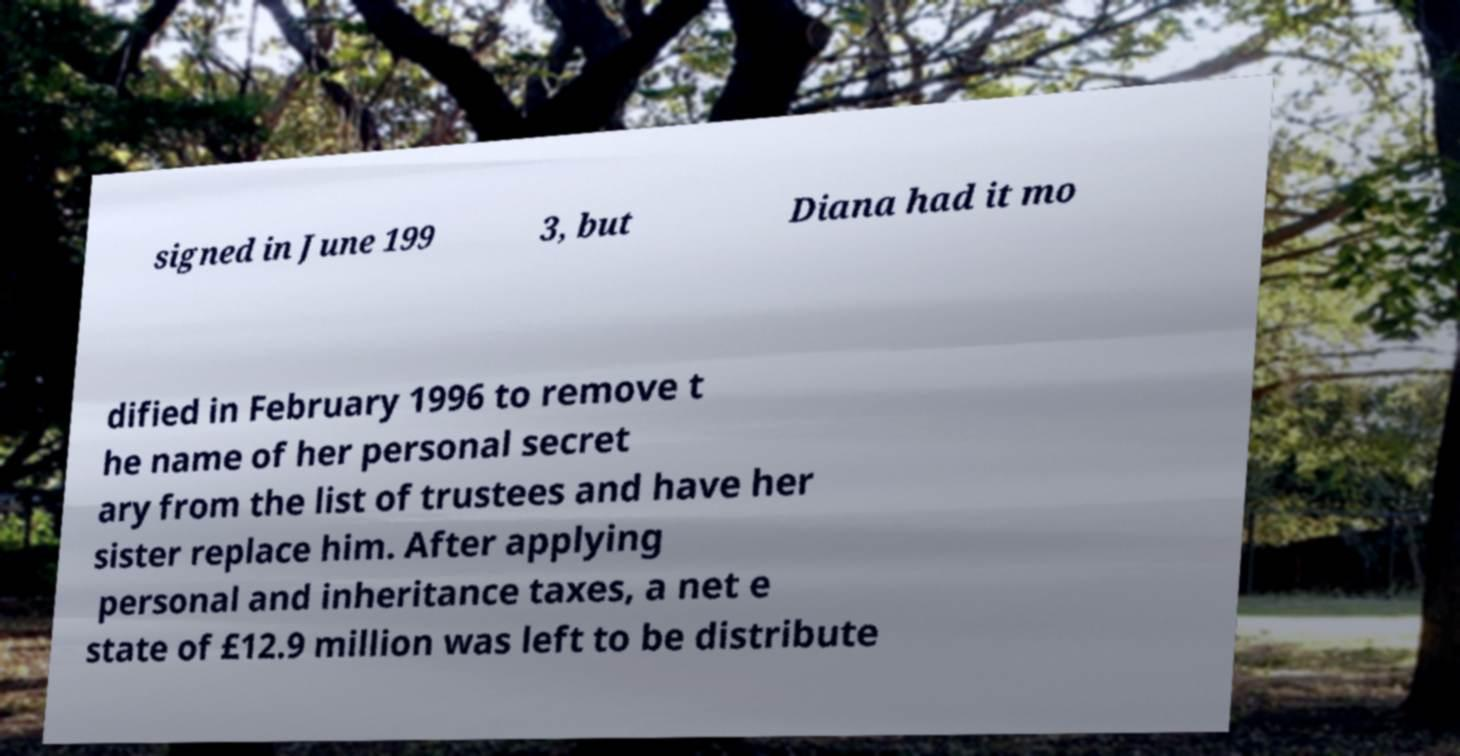Can you read and provide the text displayed in the image?This photo seems to have some interesting text. Can you extract and type it out for me? signed in June 199 3, but Diana had it mo dified in February 1996 to remove t he name of her personal secret ary from the list of trustees and have her sister replace him. After applying personal and inheritance taxes, a net e state of £12.9 million was left to be distribute 